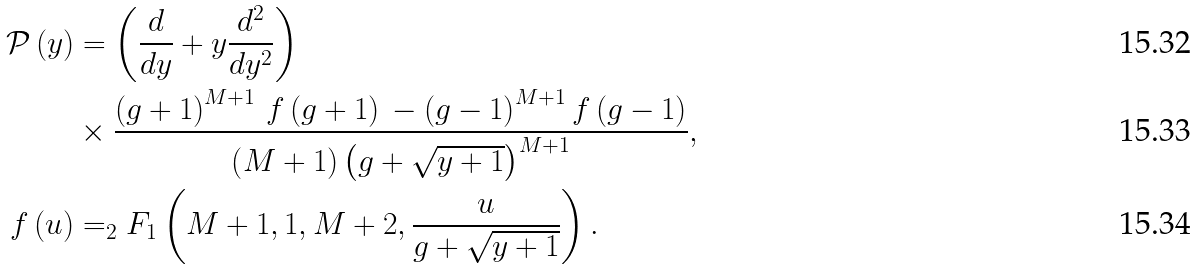<formula> <loc_0><loc_0><loc_500><loc_500>\mathcal { P } \left ( y \right ) & = \left ( \frac { d } { d y } + y \frac { d ^ { 2 } } { d y ^ { 2 } } \right ) \\ & \times \frac { \left ( g + 1 \right ) ^ { M + 1 } \, f \left ( g + 1 \right ) \, - \left ( g - 1 \right ) ^ { M + 1 } f \left ( g - 1 \right ) } { \left ( M + 1 \right ) \left ( g + \sqrt { y + 1 } \right ) ^ { M + 1 } } , \\ f \left ( u \right ) & = _ { 2 } F _ { 1 } \left ( M + 1 , 1 , M + 2 , \frac { u } { g + \sqrt { y + 1 } } \right ) .</formula> 